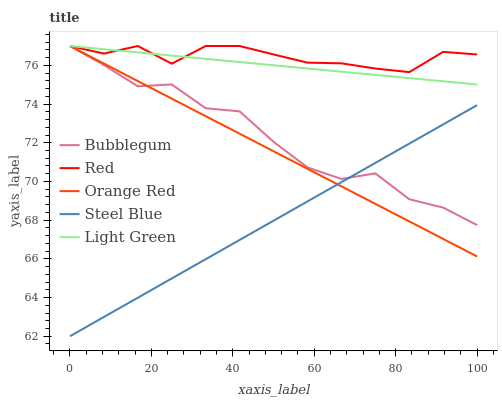Does Steel Blue have the minimum area under the curve?
Answer yes or no. Yes. Does Red have the maximum area under the curve?
Answer yes or no. Yes. Does Light Green have the minimum area under the curve?
Answer yes or no. No. Does Light Green have the maximum area under the curve?
Answer yes or no. No. Is Light Green the smoothest?
Answer yes or no. Yes. Is Bubblegum the roughest?
Answer yes or no. Yes. Is Red the smoothest?
Answer yes or no. No. Is Red the roughest?
Answer yes or no. No. Does Steel Blue have the lowest value?
Answer yes or no. Yes. Does Light Green have the lowest value?
Answer yes or no. No. Does Orange Red have the highest value?
Answer yes or no. Yes. Is Steel Blue less than Light Green?
Answer yes or no. Yes. Is Light Green greater than Steel Blue?
Answer yes or no. Yes. Does Light Green intersect Red?
Answer yes or no. Yes. Is Light Green less than Red?
Answer yes or no. No. Is Light Green greater than Red?
Answer yes or no. No. Does Steel Blue intersect Light Green?
Answer yes or no. No. 